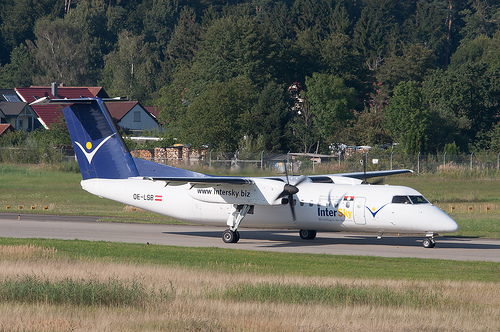If you were a bird flying over this scene, what would you observe? As a bird flying over this scene, you would observe a well-trimmed green field bordering the airport runway. You'd see the airplane parked, presumably ready for boarding or recently landed. The surroundings include a variety of trees and a few residential houses, indicating a human presence but within a relatively tranquil and green area. The bird's-eye view would afford a unique perspective on the harmony between human structures and the natural environment. What would it be like if the airplane could transform into a large bird and fly off into the forest? Imagine if the airplane, in a sudden burst of mechanical magic, started morphing into a grand, metallic bird. Its wings would unfold with a mechanical grace, feathers made of overlapping sheets of light-weight metal glistening in the sun. The propellers turn into powerful feathered wings, and the tailwing transforms into a broad, elegant tail, perfect for maneuvering. The airplane-turned-bird would take off majestically, soaring over the runway and high into the sky. As it flew towards the forest, the glint of its metallic feathers reflecting sunlight, it would harmoniously blend with the natural birds, creating a fantastic integration of technology and nature. 